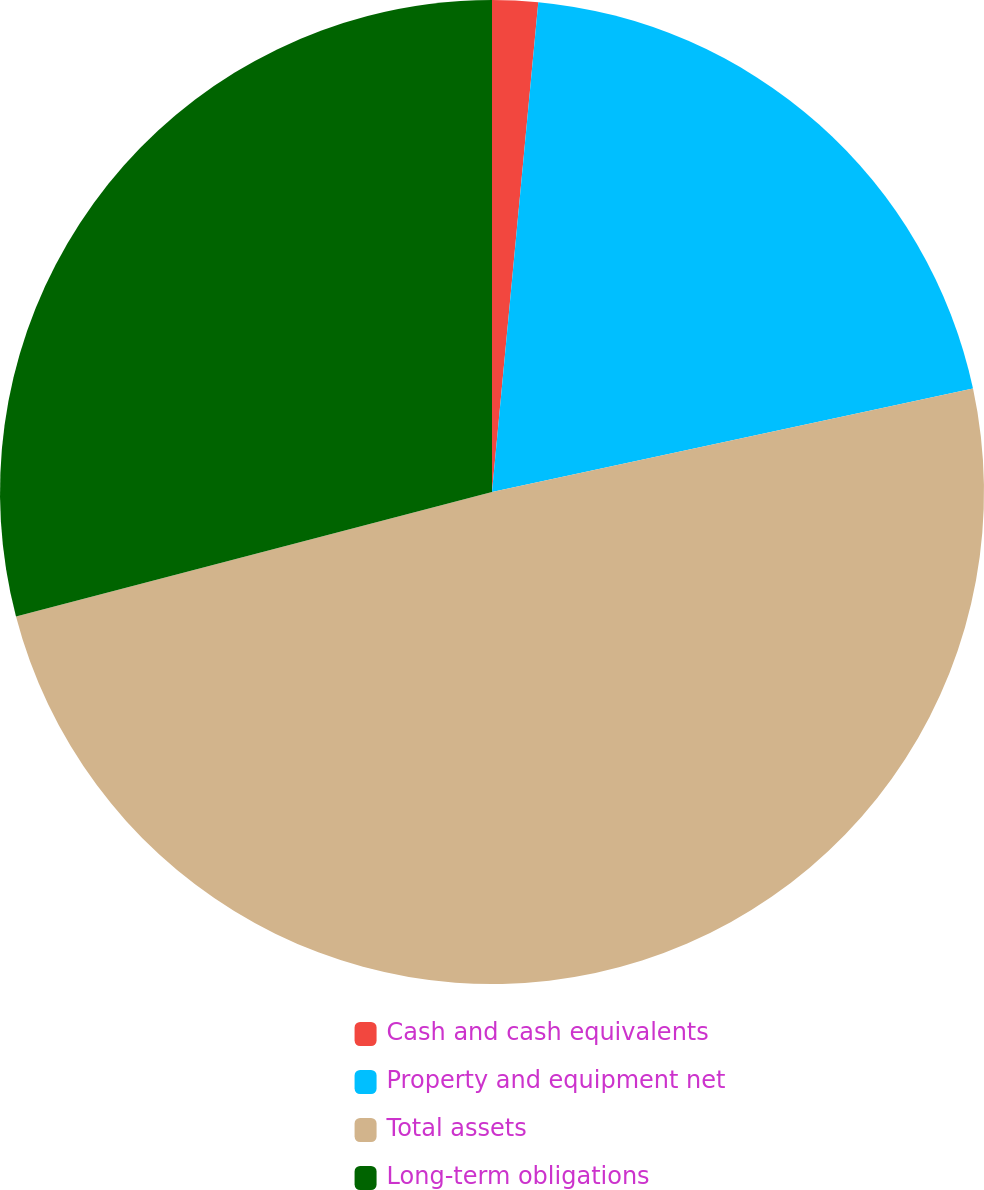Convert chart to OTSL. <chart><loc_0><loc_0><loc_500><loc_500><pie_chart><fcel>Cash and cash equivalents<fcel>Property and equipment net<fcel>Total assets<fcel>Long-term obligations<nl><fcel>1.5%<fcel>20.13%<fcel>49.3%<fcel>29.07%<nl></chart> 